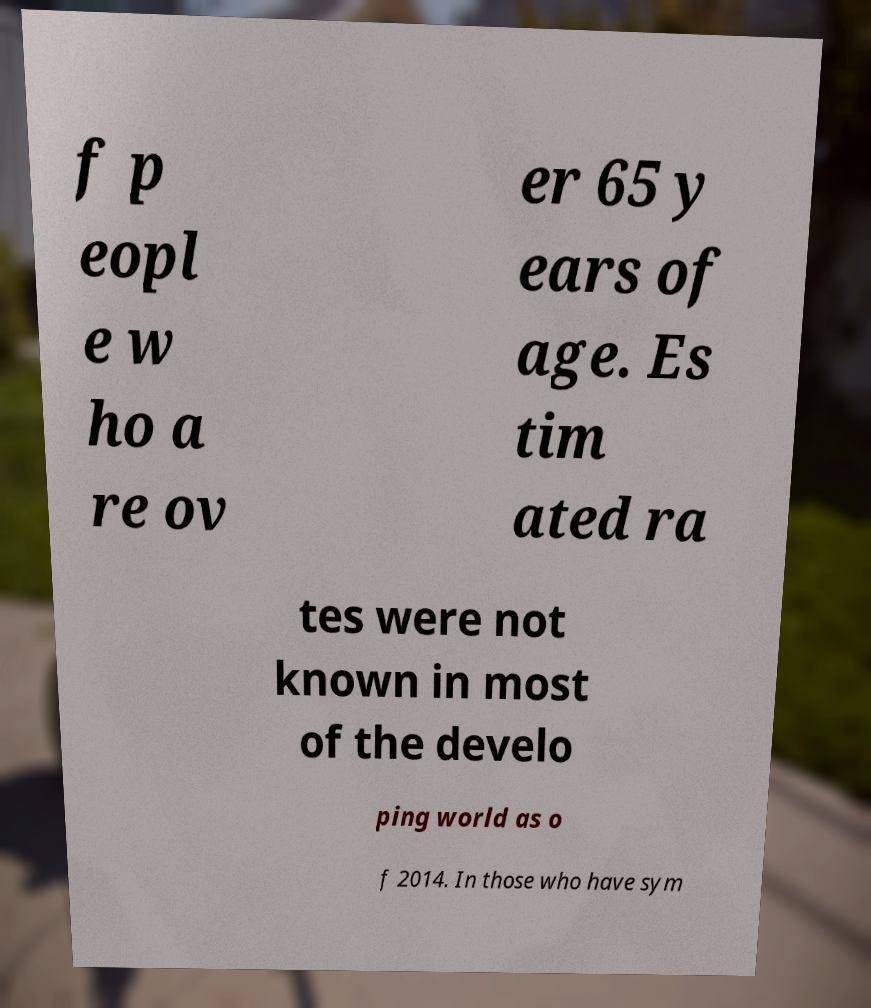Please read and relay the text visible in this image. What does it say? f p eopl e w ho a re ov er 65 y ears of age. Es tim ated ra tes were not known in most of the develo ping world as o f 2014. In those who have sym 